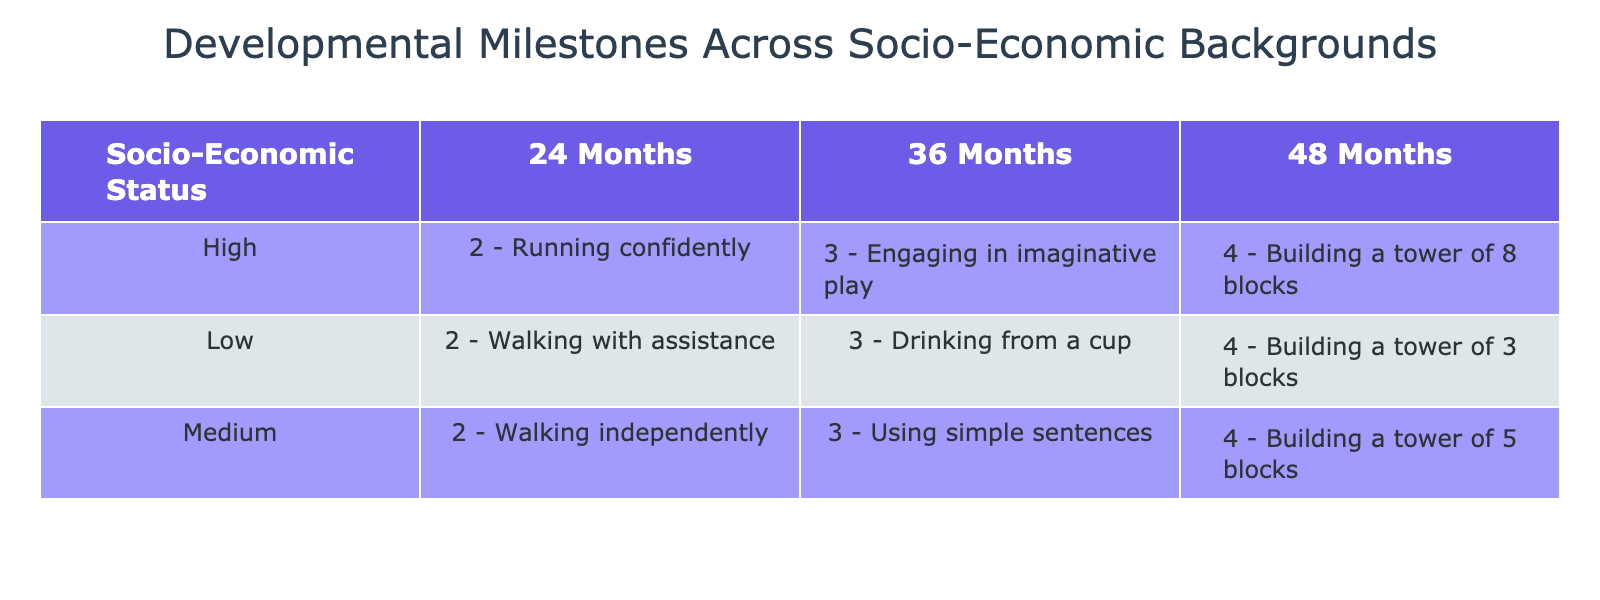What milestone is achieved by children from a low socio-economic background at 36 months? According to the table, at 36 months, children from a low socio-economic background achieve the milestone "3 - Drinking from a cup."
Answer: 3 - Drinking from a cup Which socio-economic group shows independent walking at 24 months? The table indicates that children from a medium socio-economic background achieve the milestone of walking independently at 24 months.
Answer: Medium What is the difference in the number of blocks built (milestone) between children from high and low backgrounds at 48 months? At 48 months, children from a high socio-economic background can build a tower of 8 blocks, while those from a low background build a tower of 4 blocks. The difference is 8 - 4 = 4 blocks.
Answer: 4 blocks Do all children in the high socio-economic group engage in imaginative play by 36 months? The table shows that children from the high socio-economic background achieve the milestone of engaging in imaginative play at 36 months, indicating that it is true for all in that group.
Answer: Yes What is the highest milestone achieved by children in the medium socio-economic background, and at what age? The table reveals that the highest milestone reached is "4 - Building a tower of 5 blocks," which occurs at 48 months for children in the medium socio-economic background.
Answer: 4 - Building a tower of 5 blocks at 48 months What percentage of children from a low socio-economic background can drink from a cup by 36 months compared to the total milestones recorded for that group? Looking at the low socio-economic group, there are 3 milestones recorded (age 24, 36, and 48 months). The milestone for drinking from a cup at age 36 means 1 out of 3 achieved a specific milestone, resulting in a percentage of (1/3)*100 = 33.33%.
Answer: 33.33% What milestone do children from a high socio-economic background achieve first? According to the table, at 24 months, children from a high socio-economic background achieve "2 - Running confidently." This is the first milestone listed for this group.
Answer: 2 - Running confidently Is drinking from a cup an earlier milestone than building a tower of blocks for children in a low socio-economic group? Drinking from a cup is achieved at 36 months, while building a tower of 3 blocks occurs at 48 months. Therefore, drinking from a cup is indeed an earlier milestone.
Answer: Yes What are the milestones achieved by children in a medium socio-economic background at both 24 and 48 months? At 24 months, children from the medium socio-economic background achieve "2 - Walking independently," and at 48 months, they achieve "4 - Building a tower of 5 blocks." These are the milestones for those ages.
Answer: 2 - Walking independently at 24 months; 4 - Building a tower of 5 blocks at 48 months 